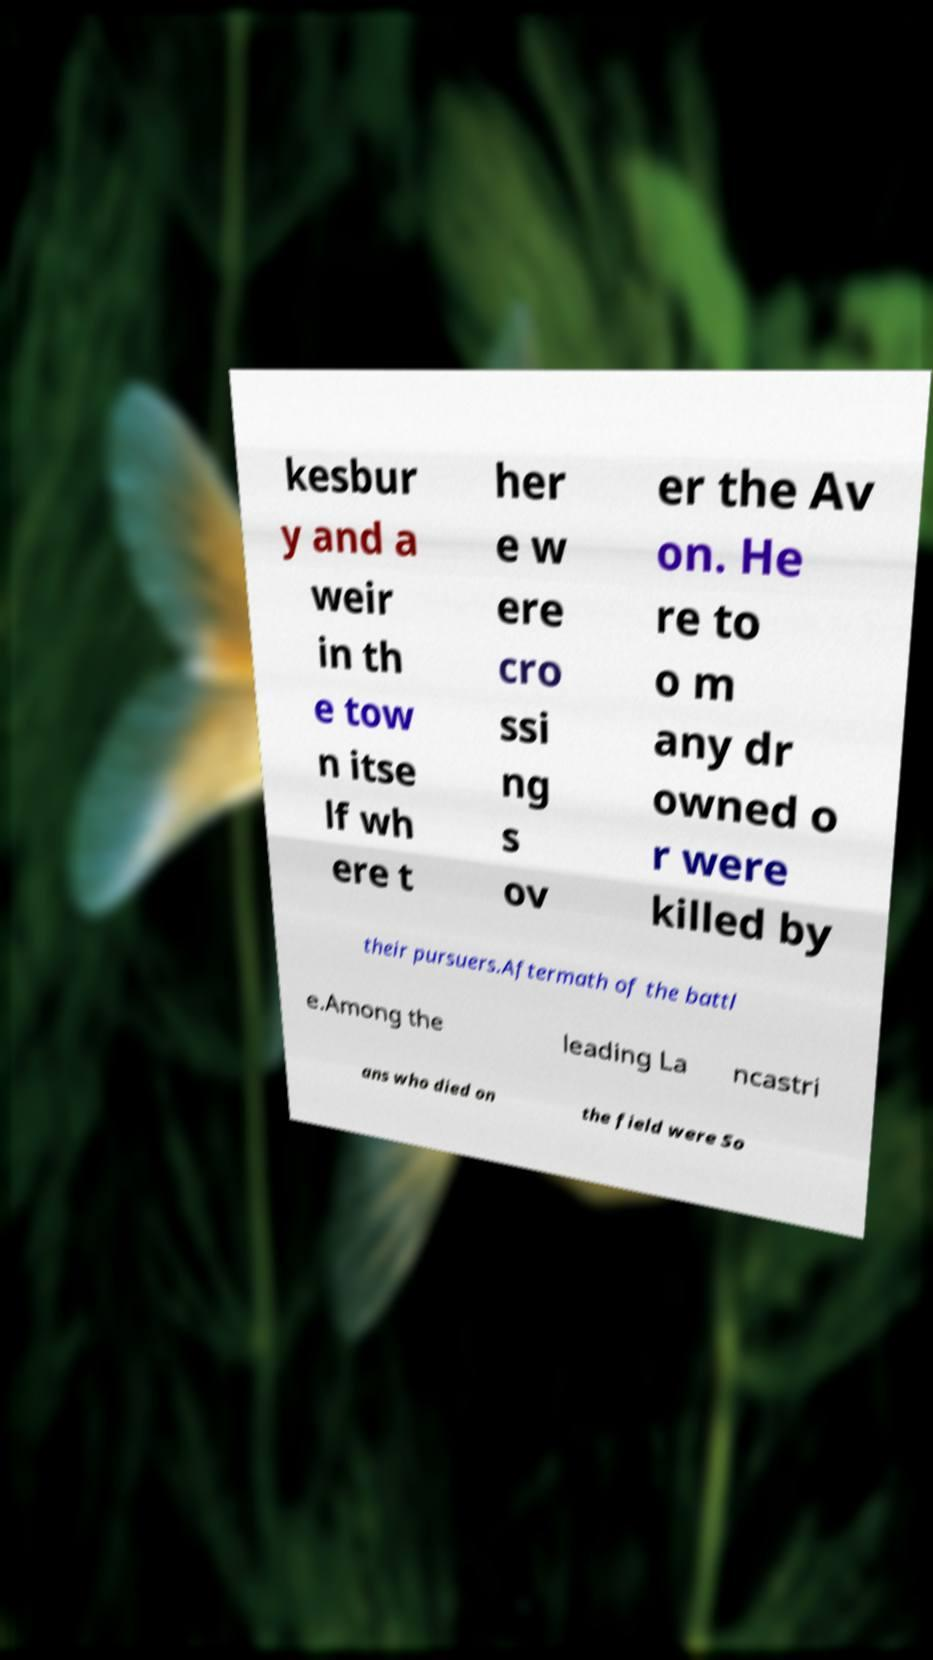There's text embedded in this image that I need extracted. Can you transcribe it verbatim? kesbur y and a weir in th e tow n itse lf wh ere t her e w ere cro ssi ng s ov er the Av on. He re to o m any dr owned o r were killed by their pursuers.Aftermath of the battl e.Among the leading La ncastri ans who died on the field were So 